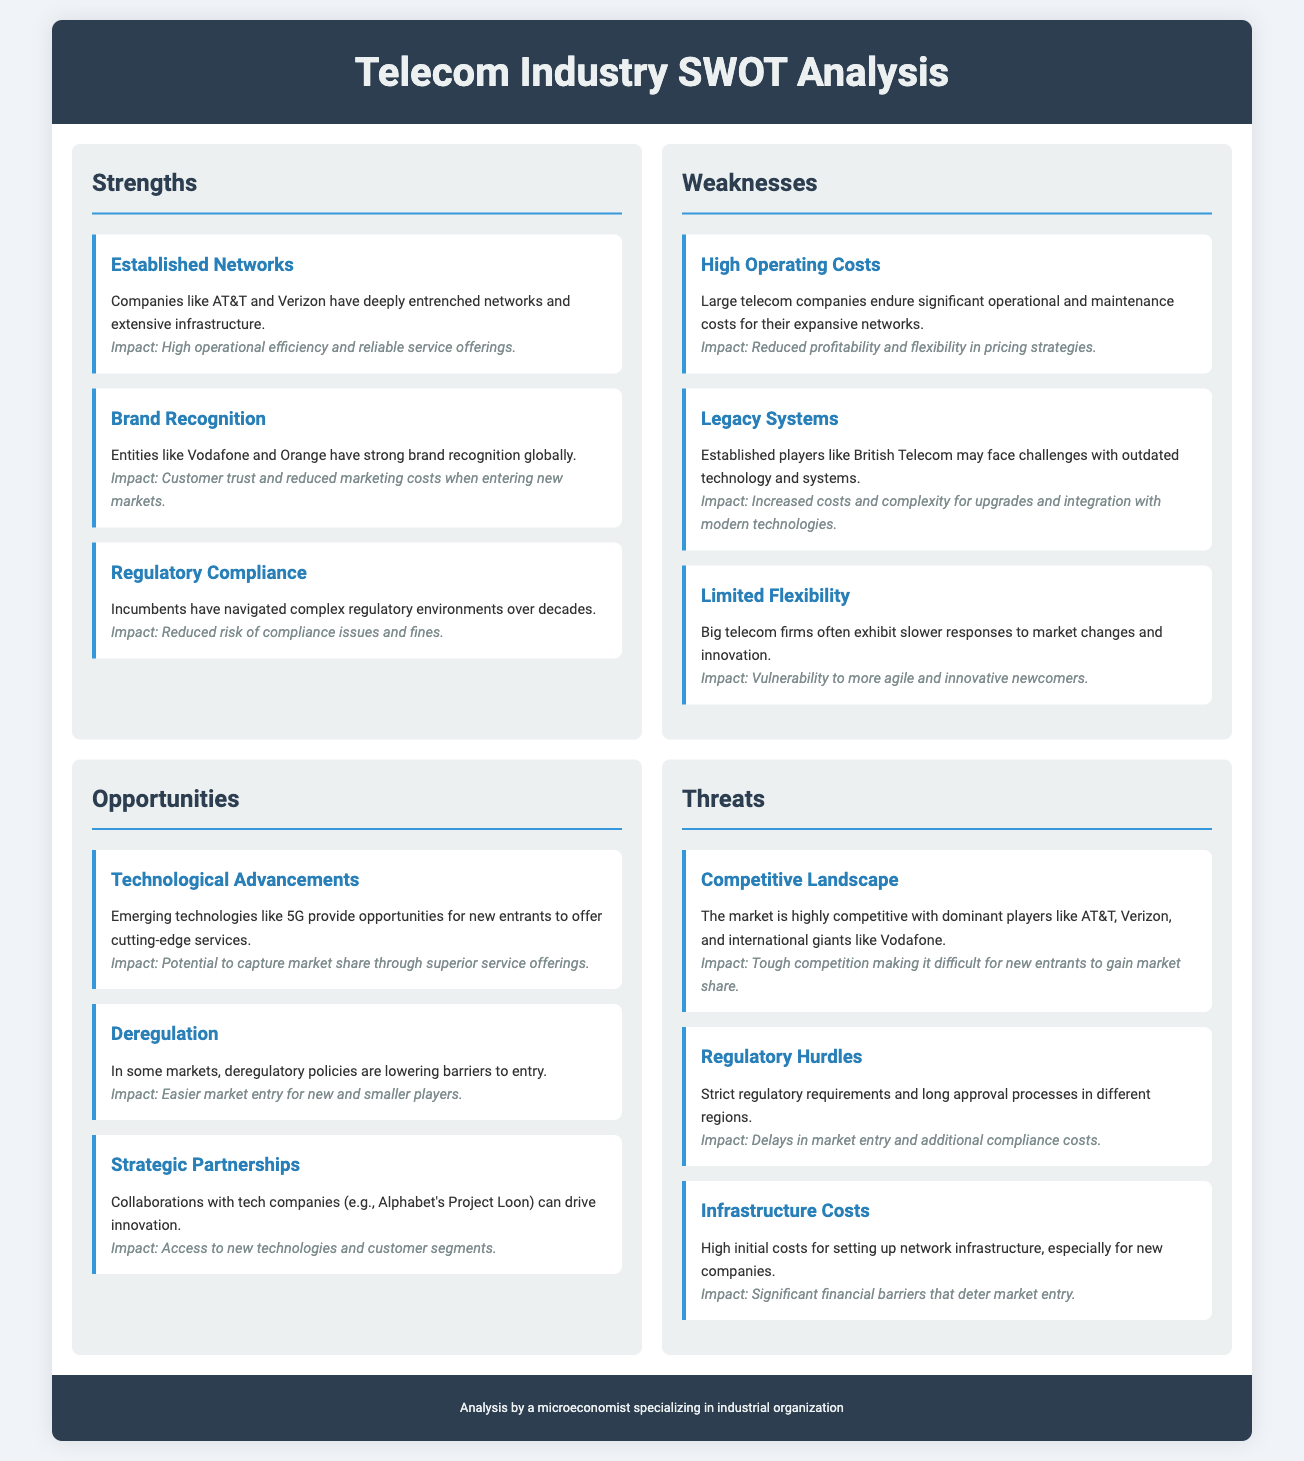what is a significant strength of telecommunications companies? Established Networks is listed as a significant strength, highlighting the deep networks and extensive infrastructure that companies like AT&T and Verizon possess.
Answer: Established Networks which weakness involves technology challenges? Legacy Systems mentions challenges with outdated technology and systems faced by established players like British Telecom.
Answer: Legacy Systems what opportunity is linked to emerging technologies? Technological Advancements refers to emerging technologies like 5G which provide opportunities for new entrants.
Answer: Technological Advancements which threat is associated with high costs for new companies? Infrastructure Costs specifies high initial costs for setting up network infrastructure as a threat to new companies.
Answer: Infrastructure Costs how does brand recognition impact market entry? Brand Recognition states that strong brand recognition globally reduces marketing costs when entering new markets.
Answer: Reduced marketing costs what is one major regulatory issue for new entrants? Regulatory Hurdles indicate that strict regulatory requirements pose significant issues for new entrants in various regions.
Answer: Strict regulatory requirements which telecommunications companies are primarily mentioned as dominant players? The Competitive Landscape section highlights AT&T, Verizon, and international giants like Vodafone as dominant players.
Answer: AT&T, Verizon, Vodafone what is the potential impact of deregulation on new entrants? Deregulation notes that such policies lower barriers to entry, making it easier for new and smaller players to enter the market.
Answer: Easier market entry 